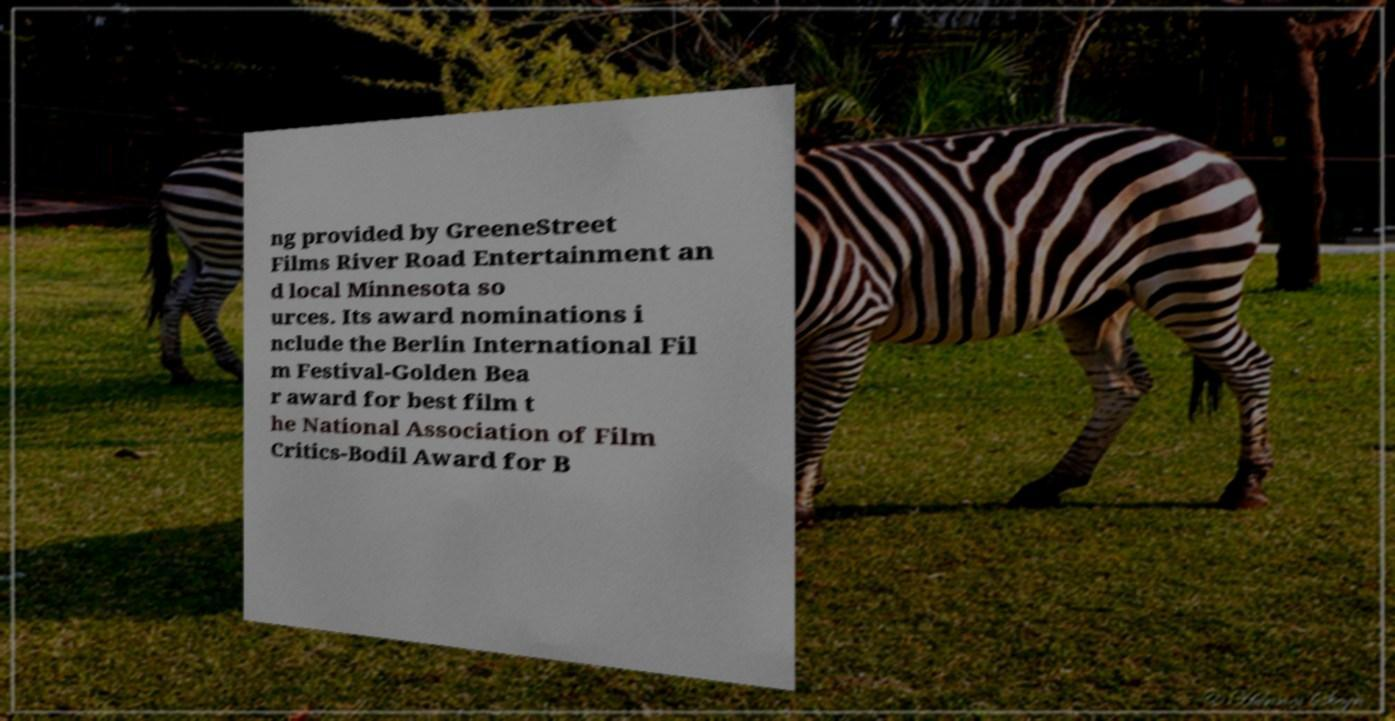Could you extract and type out the text from this image? ng provided by GreeneStreet Films River Road Entertainment an d local Minnesota so urces. Its award nominations i nclude the Berlin International Fil m Festival-Golden Bea r award for best film t he National Association of Film Critics-Bodil Award for B 